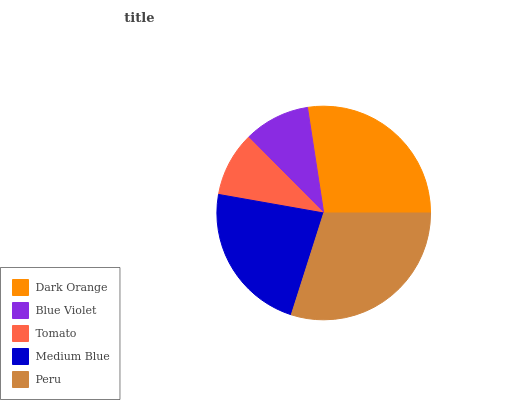Is Tomato the minimum?
Answer yes or no. Yes. Is Peru the maximum?
Answer yes or no. Yes. Is Blue Violet the minimum?
Answer yes or no. No. Is Blue Violet the maximum?
Answer yes or no. No. Is Dark Orange greater than Blue Violet?
Answer yes or no. Yes. Is Blue Violet less than Dark Orange?
Answer yes or no. Yes. Is Blue Violet greater than Dark Orange?
Answer yes or no. No. Is Dark Orange less than Blue Violet?
Answer yes or no. No. Is Medium Blue the high median?
Answer yes or no. Yes. Is Medium Blue the low median?
Answer yes or no. Yes. Is Blue Violet the high median?
Answer yes or no. No. Is Dark Orange the low median?
Answer yes or no. No. 